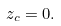Convert formula to latex. <formula><loc_0><loc_0><loc_500><loc_500>z _ { c } = 0 .</formula> 